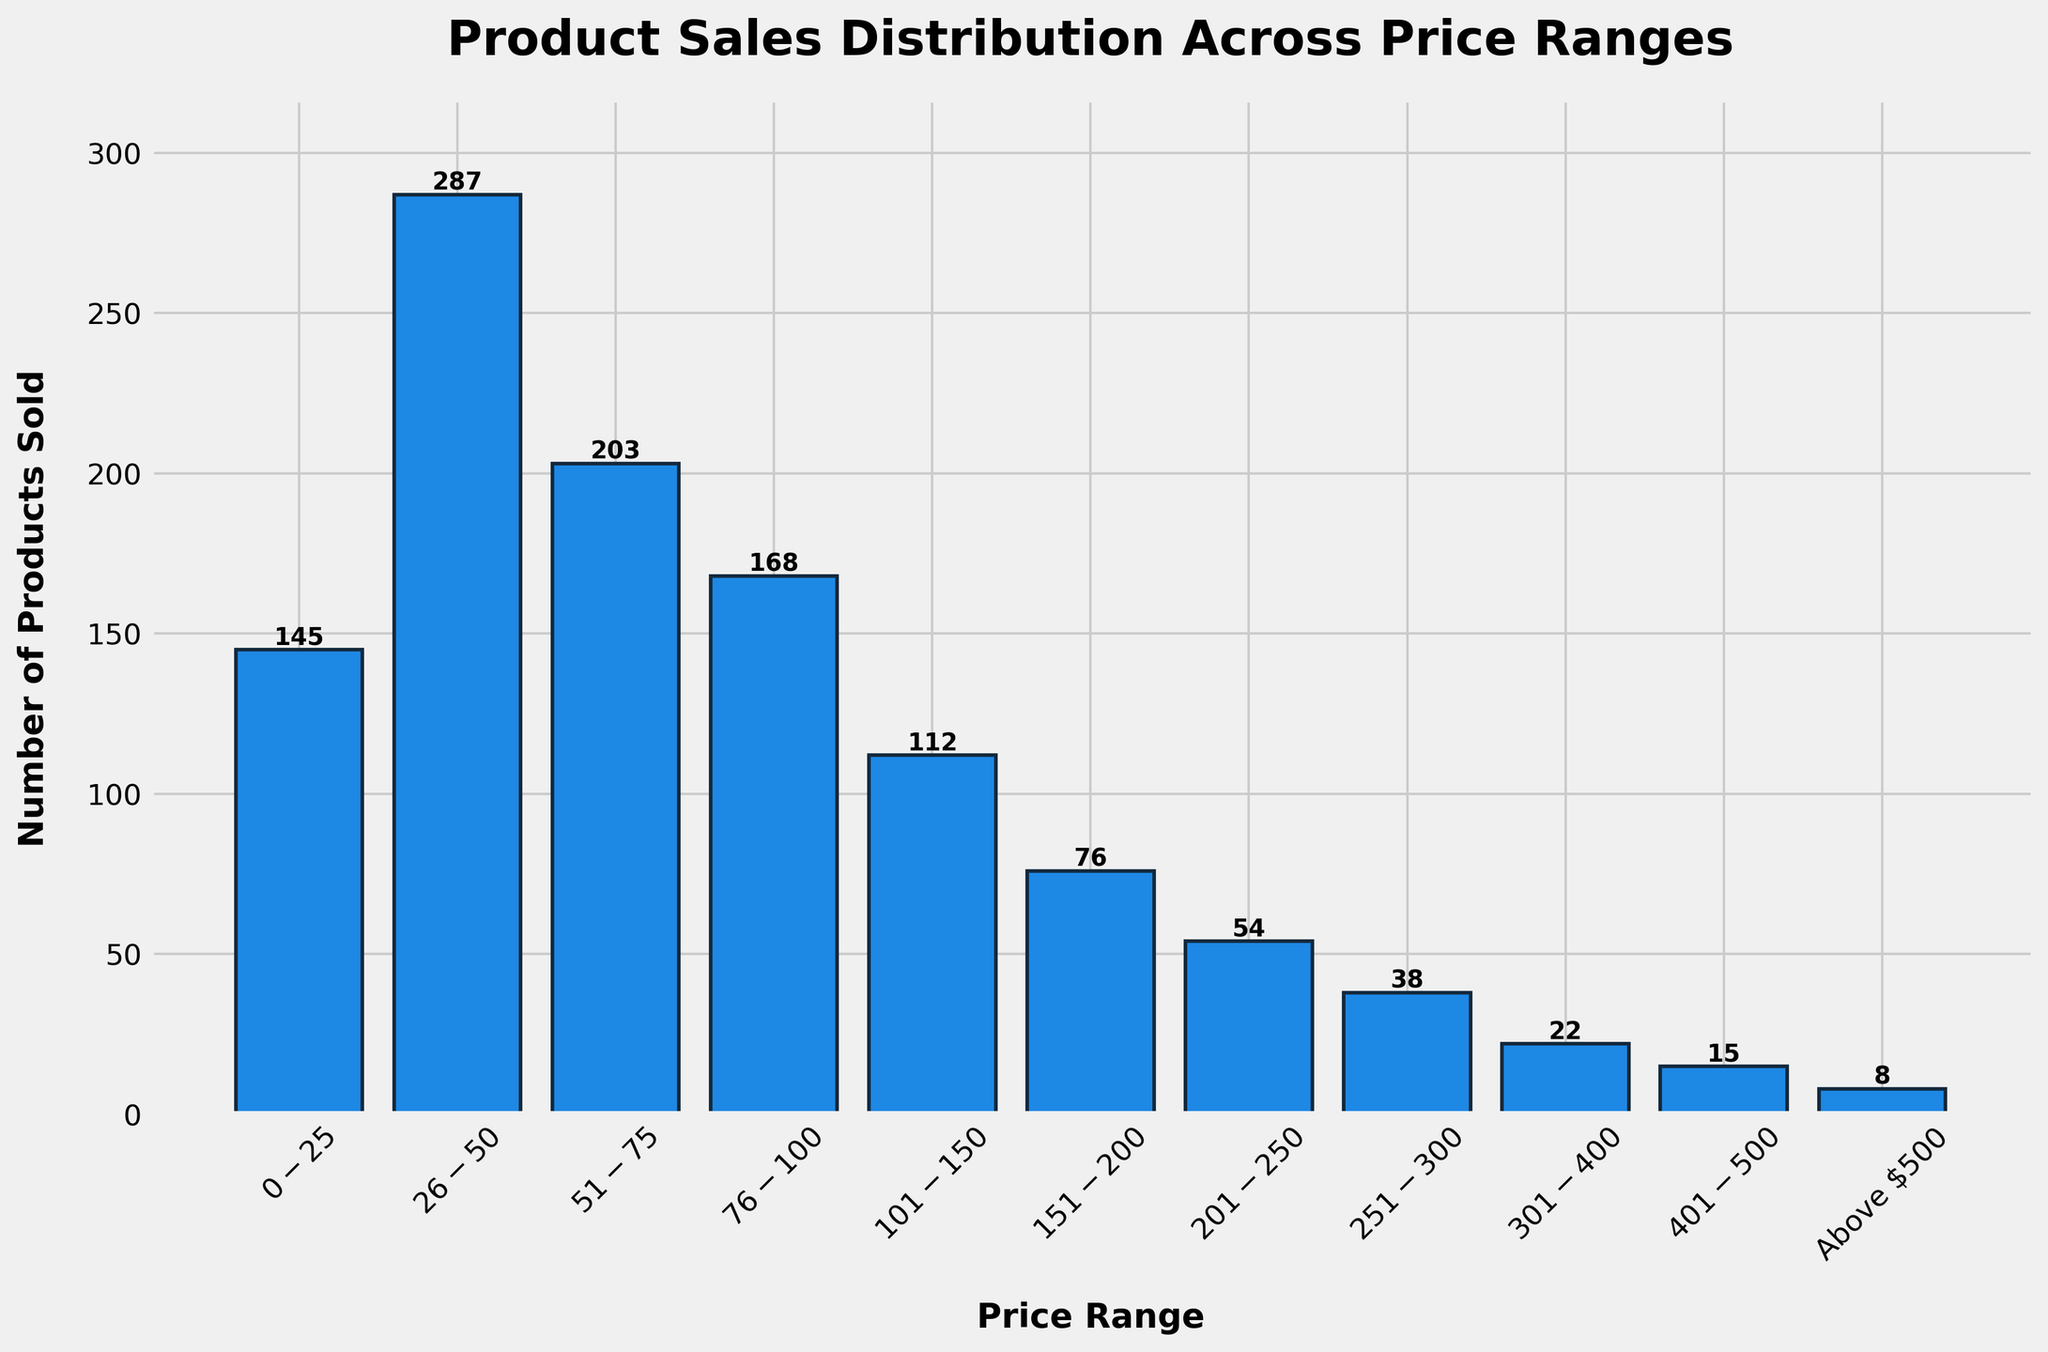What is the title of the histogram? The title is displayed at the top of the figure. It reads "Product Sales Distribution Across Price Ranges" in bold, large font.
Answer: Product Sales Distribution Across Price Ranges How many price ranges are shown in the histogram? By counting the labeled categories on the x-axis, we can see there are 11 different price ranges shown in the histogram.
Answer: 11 Which price range has the highest number of products sold? By identifying the tallest bar in the histogram, we see that the price range $26-$50 has the highest bar with 287 products sold.
Answer: $26-$50 What is the number of products sold for the price range $76-$100? This information can be read directly from the height of the corresponding bar in the histogram, which is labeled with the value 168.
Answer: 168 What is the total number of products sold for price ranges below $100? Sum the number of products sold for the price ranges $0-$25, $26-$50, $51-$75, and $76-$100: 145 + 287 + 203 + 168 = 803.
Answer: 803 How does the number of products sold in the $151-$200 range compare to the $201-$250 range? The bar for $151-$200 has a height of 76, while the bar for $201-$250 has a height of 54. Comparing these, 76 is greater than 54.
Answer: $151-$200 has more products sold Which price range has the fewest number of products sold? By identifying the shortest bar in the histogram, we see that the "Above $500" range has the lowest bar with 8 products sold.
Answer: Above $500 Are there more products sold in the $101-$150 range or in the $251-$300 range? By comparing the heights of the bars, the $101-$150 range has 112 products sold, whereas the $251-$300 range has 38 products sold. Therefore, there are more products sold in the $101-$150 range.
Answer: $101-$150 What is the sum of products sold in the ranges $401-$500 and Above $500? Add the number of products sold for the $401-$500 range and Above $500 range: 15 + 8 = 23.
Answer: 23 Describe the distribution of sales across price ranges in general. By observing the histogram, it is clear that the number of products sold diminishes as the price range increases. Most of the products are sold within the lower price ranges, with a peak at $26-$50 and a gradual decline as price ranges increase. Very few products are sold at the higher price ranges, such as $401-$500 and Above $500.
Answer: Most sales are in lower price ranges, peaking at $26-$50, with a decline in higher price ranges 